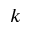Convert formula to latex. <formula><loc_0><loc_0><loc_500><loc_500>k</formula> 